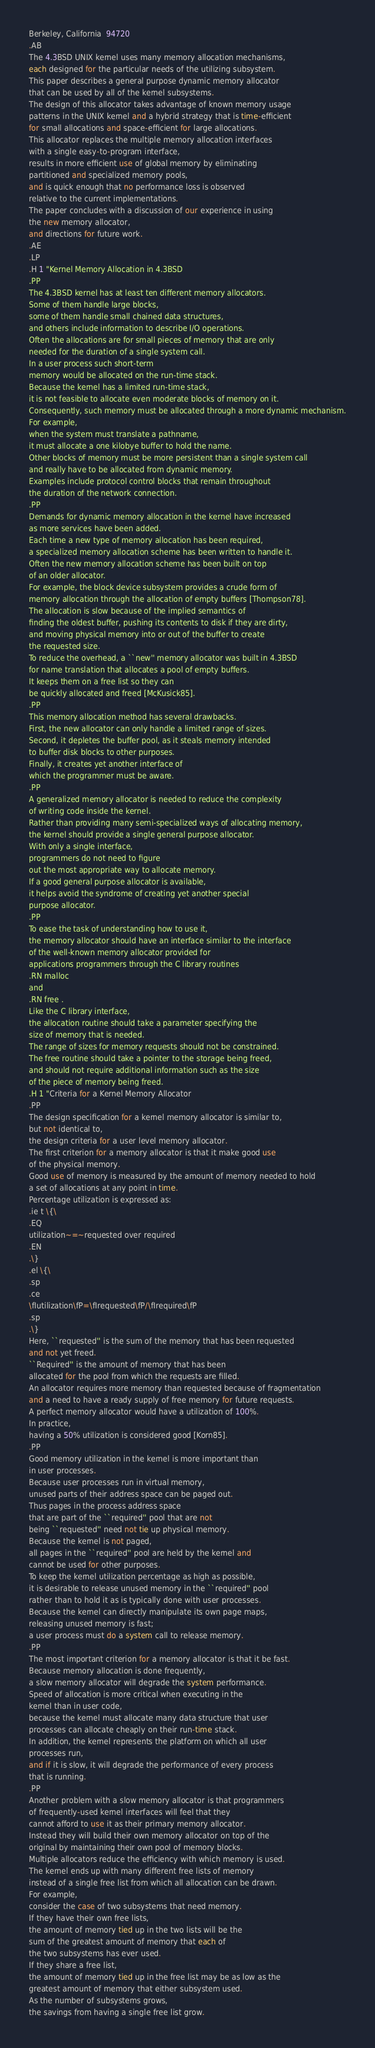<code> <loc_0><loc_0><loc_500><loc_500><_Perl_>Berkeley, California  94720
.AB
The 4.3BSD UNIX kernel uses many memory allocation mechanisms,
each designed for the particular needs of the utilizing subsystem.
This paper describes a general purpose dynamic memory allocator
that can be used by all of the kernel subsystems.
The design of this allocator takes advantage of known memory usage
patterns in the UNIX kernel and a hybrid strategy that is time-efficient
for small allocations and space-efficient for large allocations.
This allocator replaces the multiple memory allocation interfaces 
with a single easy-to-program interface,
results in more efficient use of global memory by eliminating
partitioned and specialized memory pools,
and is quick enough that no performance loss is observed
relative to the current implementations.
The paper concludes with a discussion of our experience in using
the new memory allocator,
and directions for future work.
.AE
.LP
.H 1 "Kernel Memory Allocation in 4.3BSD
.PP
The 4.3BSD kernel has at least ten different memory allocators.
Some of them handle large blocks,
some of them handle small chained data structures,
and others include information to describe I/O operations.
Often the allocations are for small pieces of memory that are only
needed for the duration of a single system call.
In a user process such short-term
memory would be allocated on the run-time stack.
Because the kernel has a limited run-time stack,
it is not feasible to allocate even moderate blocks of memory on it.
Consequently, such memory must be allocated through a more dynamic mechanism.
For example,
when the system must translate a pathname,
it must allocate a one kilobye buffer to hold the name.
Other blocks of memory must be more persistent than a single system call
and really have to be allocated from dynamic memory.
Examples include protocol control blocks that remain throughout
the duration of the network connection.
.PP
Demands for dynamic memory allocation in the kernel have increased
as more services have been added.
Each time a new type of memory allocation has been required,
a specialized memory allocation scheme has been written to handle it.
Often the new memory allocation scheme has been built on top
of an older allocator.
For example, the block device subsystem provides a crude form of
memory allocation through the allocation of empty buffers [Thompson78].
The allocation is slow because of the implied semantics of
finding the oldest buffer, pushing its contents to disk if they are dirty,
and moving physical memory into or out of the buffer to create 
the requested size.
To reduce the overhead, a ``new'' memory allocator was built in 4.3BSD
for name translation that allocates a pool of empty buffers.
It keeps them on a free list so they can
be quickly allocated and freed [McKusick85].
.PP
This memory allocation method has several drawbacks.
First, the new allocator can only handle a limited range of sizes.
Second, it depletes the buffer pool, as it steals memory intended
to buffer disk blocks to other purposes.
Finally, it creates yet another interface of
which the programmer must be aware.
.PP
A generalized memory allocator is needed to reduce the complexity
of writing code inside the kernel.
Rather than providing many semi-specialized ways of allocating memory,
the kernel should provide a single general purpose allocator.
With only a single interface, 
programmers do not need to figure
out the most appropriate way to allocate memory.
If a good general purpose allocator is available,
it helps avoid the syndrome of creating yet another special
purpose allocator.
.PP
To ease the task of understanding how to use it,
the memory allocator should have an interface similar to the interface
of the well-known memory allocator provided for
applications programmers through the C library routines
.RN malloc
and
.RN free .
Like the C library interface,
the allocation routine should take a parameter specifying the
size of memory that is needed.
The range of sizes for memory requests should not be constrained.
The free routine should take a pointer to the storage being freed,
and should not require additional information such as the size
of the piece of memory being freed.
.H 1 "Criteria for a Kernel Memory Allocator
.PP
The design specification for a kernel memory allocator is similar to,
but not identical to,
the design criteria for a user level memory allocator.
The first criterion for a memory allocator is that it make good use
of the physical memory.
Good use of memory is measured by the amount of memory needed to hold
a set of allocations at any point in time.
Percentage utilization is expressed as:
.ie t \{\
.EQ
utilization~=~requested over required
.EN
.\}
.el \{\
.sp
.ce
\fIutilization\fP=\fIrequested\fP/\fIrequired\fP
.sp
.\}
Here, ``requested'' is the sum of the memory that has been requested
and not yet freed.
``Required'' is the amount of memory that has been
allocated for the pool from which the requests are filled.
An allocator requires more memory than requested because of fragmentation
and a need to have a ready supply of free memory for future requests.
A perfect memory allocator would have a utilization of 100%.
In practice,
having a 50% utilization is considered good [Korn85].
.PP
Good memory utilization in the kernel is more important than
in user processes.
Because user processes run in virtual memory,
unused parts of their address space can be paged out.
Thus pages in the process address space
that are part of the ``required'' pool that are not
being ``requested'' need not tie up physical memory.
Because the kernel is not paged,
all pages in the ``required'' pool are held by the kernel and
cannot be used for other purposes.
To keep the kernel utilization percentage as high as possible,
it is desirable to release unused memory in the ``required'' pool
rather than to hold it as is typically done with user processes.
Because the kernel can directly manipulate its own page maps,
releasing unused memory is fast;
a user process must do a system call to release memory.
.PP
The most important criterion for a memory allocator is that it be fast.
Because memory allocation is done frequently,
a slow memory allocator will degrade the system performance.
Speed of allocation is more critical when executing in the
kernel than in user code,
because the kernel must allocate many data structure that user
processes can allocate cheaply on their run-time stack.
In addition, the kernel represents the platform on which all user
processes run,
and if it is slow, it will degrade the performance of every process
that is running.
.PP
Another problem with a slow memory allocator is that programmers
of frequently-used kernel interfaces will feel that they
cannot afford to use it as their primary memory allocator. 
Instead they will build their own memory allocator on top of the
original by maintaining their own pool of memory blocks.
Multiple allocators reduce the efficiency with which memory is used.
The kernel ends up with many different free lists of memory
instead of a single free list from which all allocation can be drawn.
For example,
consider the case of two subsystems that need memory.
If they have their own free lists,
the amount of memory tied up in the two lists will be the
sum of the greatest amount of memory that each of
the two subsystems has ever used.
If they share a free list,
the amount of memory tied up in the free list may be as low as the
greatest amount of memory that either subsystem used.
As the number of subsystems grows,
the savings from having a single free list grow.</code> 